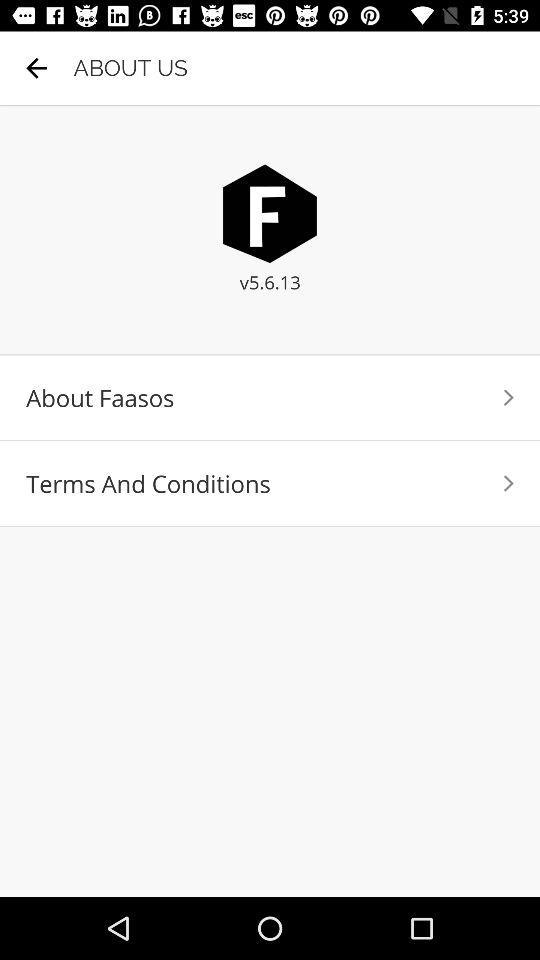What is the name of the application? The name of the application is "Faasos". 